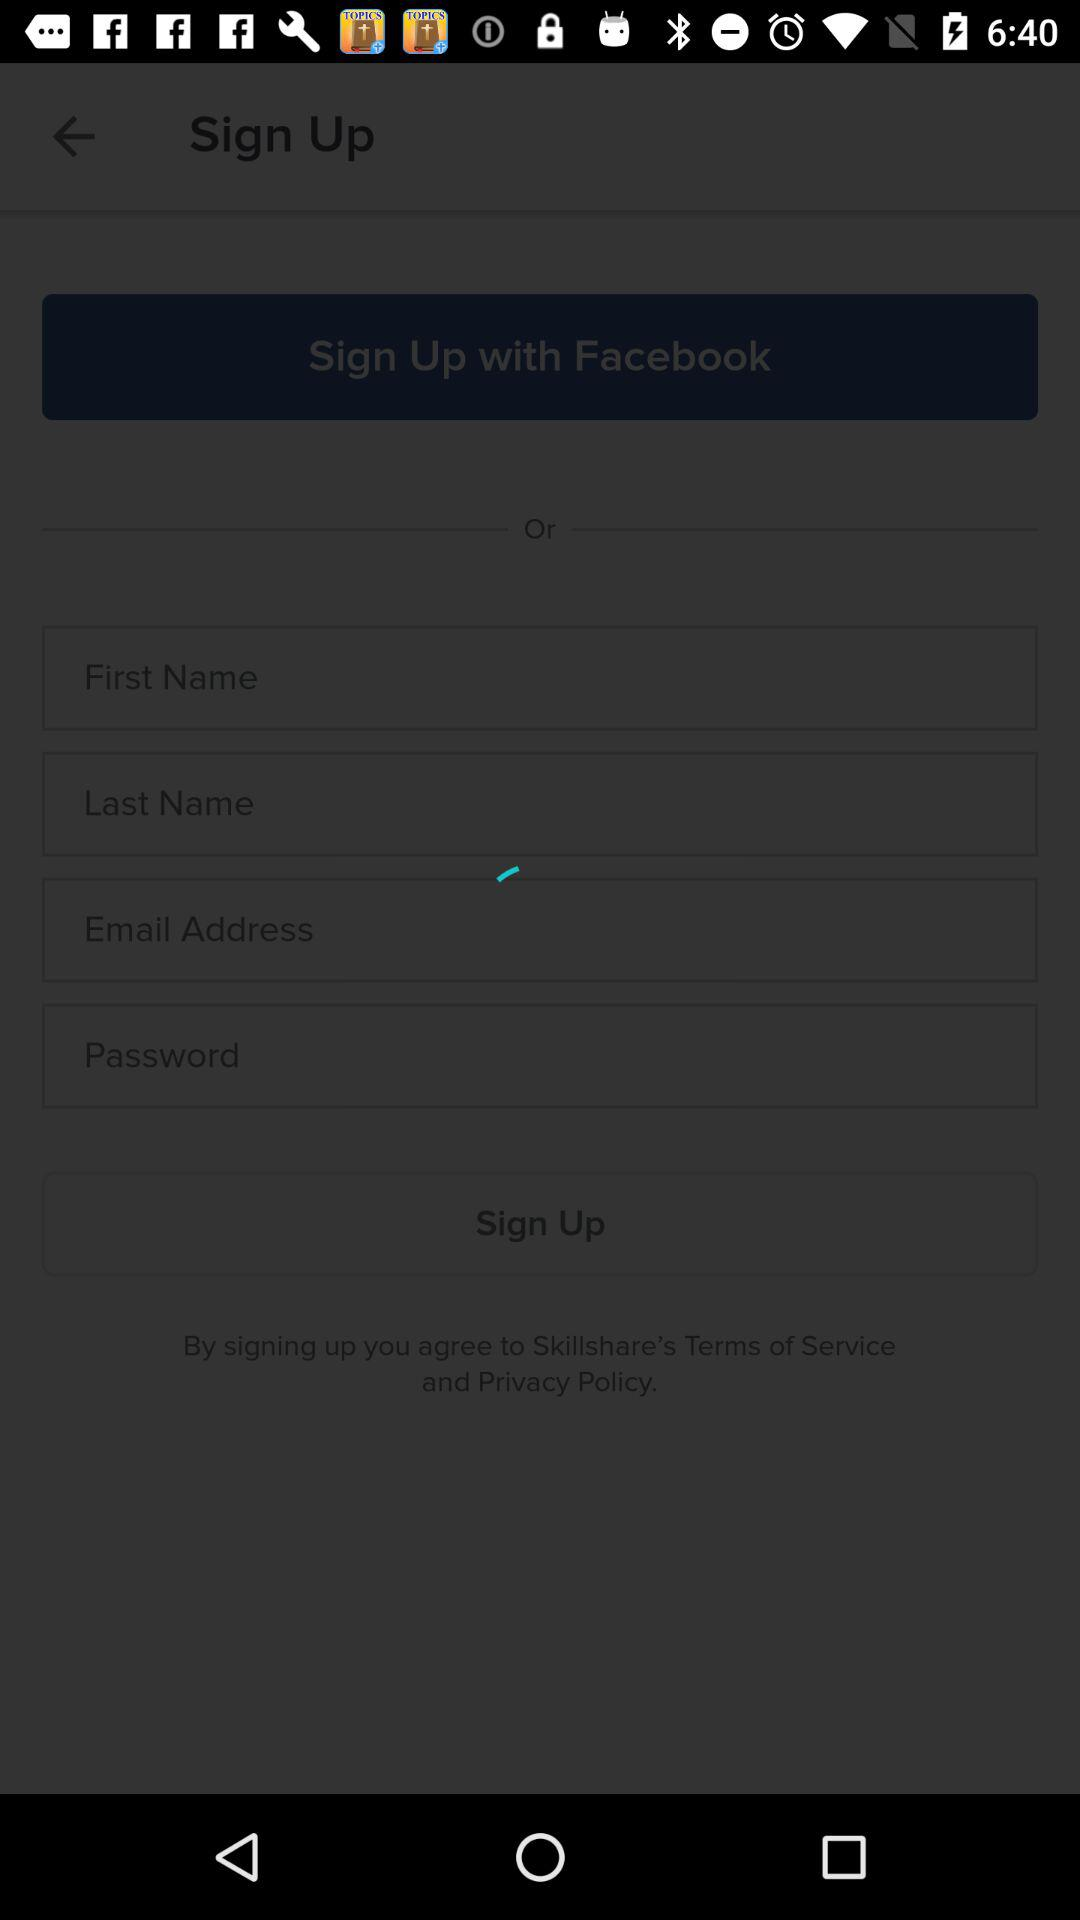How many text inputs are there for signing up?
Answer the question using a single word or phrase. 4 